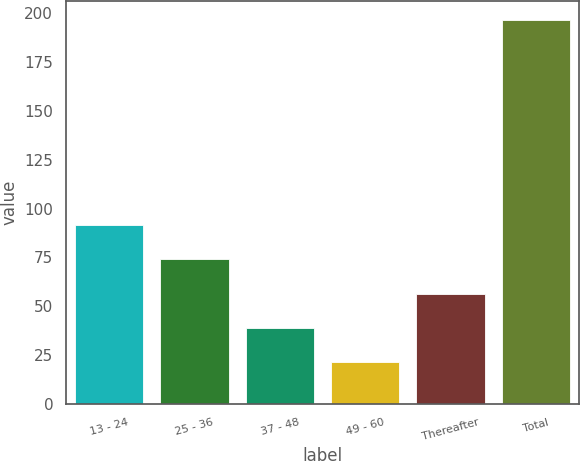Convert chart to OTSL. <chart><loc_0><loc_0><loc_500><loc_500><bar_chart><fcel>13 - 24<fcel>25 - 36<fcel>37 - 48<fcel>49 - 60<fcel>Thereafter<fcel>Total<nl><fcel>91.48<fcel>73.96<fcel>38.92<fcel>21.4<fcel>56.44<fcel>196.6<nl></chart> 